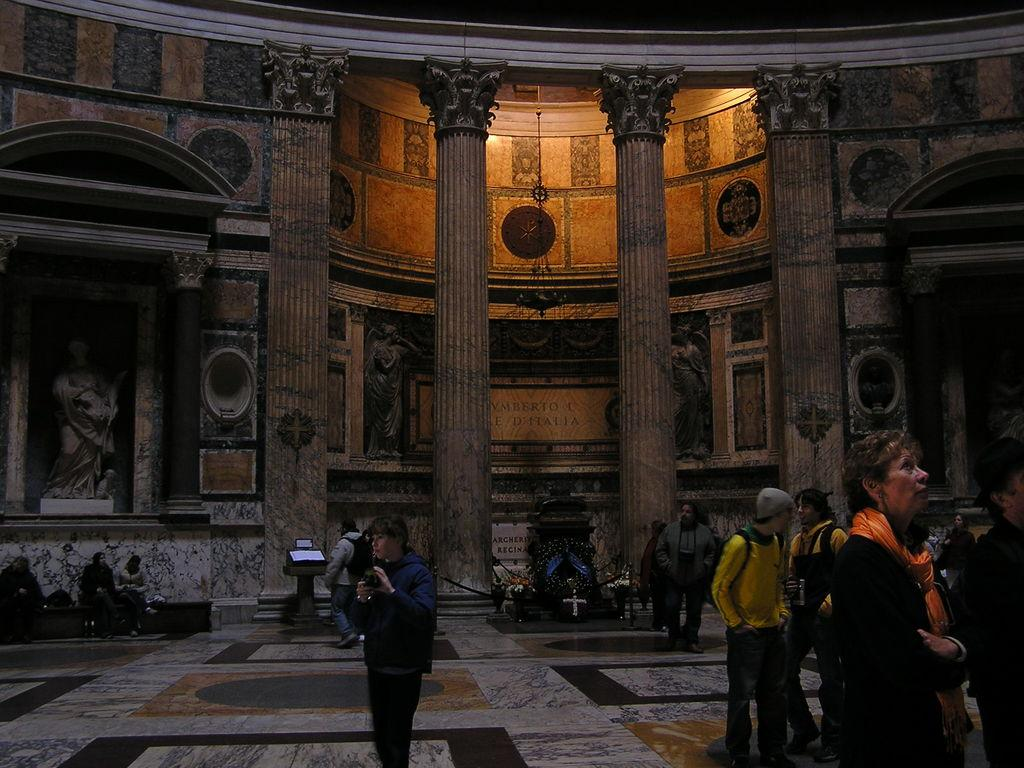How many people are in the image? There are people in the image, but the exact number is not specified. What is the surface beneath the people's feet in the image? There is a floor visible in the image. What is the purpose of the screen on a stand in the image? The purpose of the screen on a stand is not specified, but it is likely for displaying information or media. What type of architectural feature can be seen in the image? There are pillars in the image. What are the boards used for in the image? The purpose of the boards is not specified, but they may be used for displaying information or as part of a structure. What type of artwork is on the wall in the image? There is a painting on the wall in the image. What objects can be seen in the image? There are objects in the image, but their specific nature is not specified. How many crates are stacked on top of each other in the image? There are no crates present in the image. What type of sorting method is being used by the people in the image? There is no indication of any sorting activity in the image. What emotion can be seen on the faces of the people in the image? The emotion of the people in the image is not specified. 